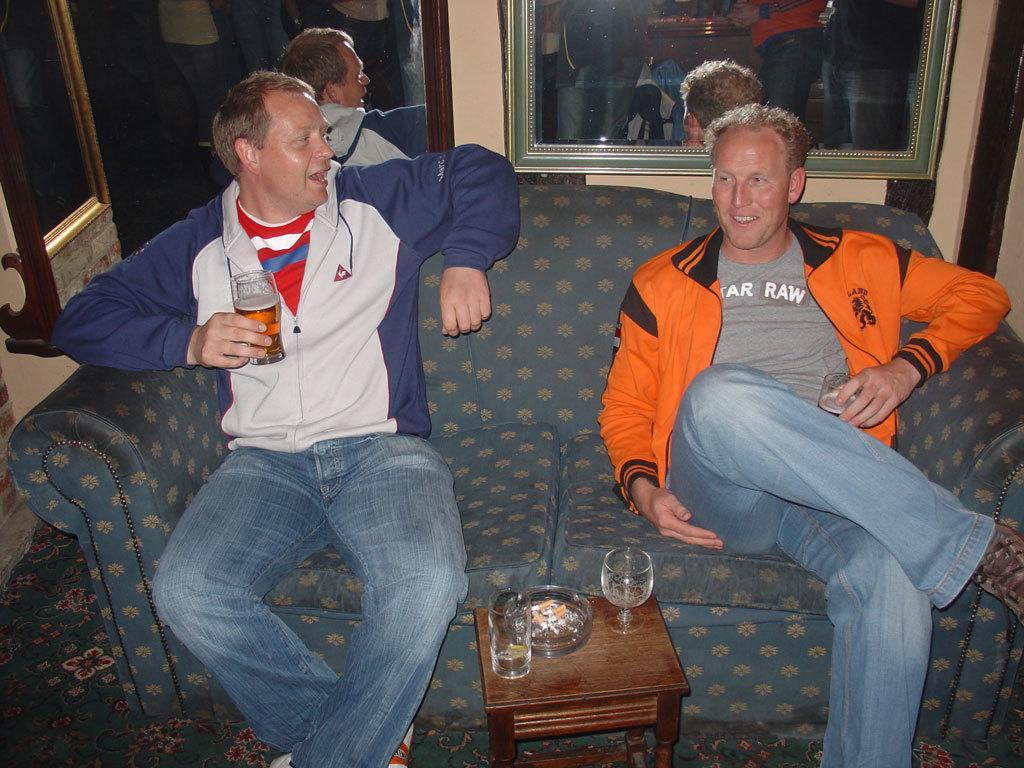Can you describe this image briefly? In this picture we can see two men, they are sitting on the sofa and they are holding glasses, in front of them we can see glasses and a ashtray on the table, behind them we can see a frame on the wall, we can see few more people in the reflection. 